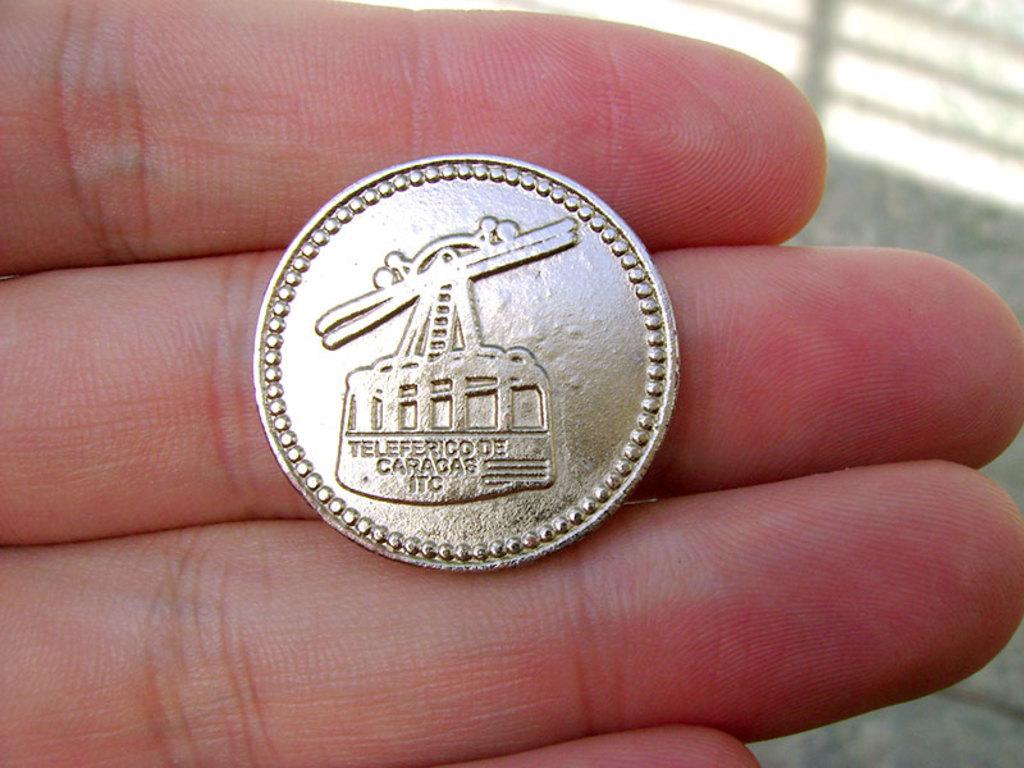In one or two sentences, can you explain what this image depicts? Here in this picture we can see a coin present on a person's fingers over there. 